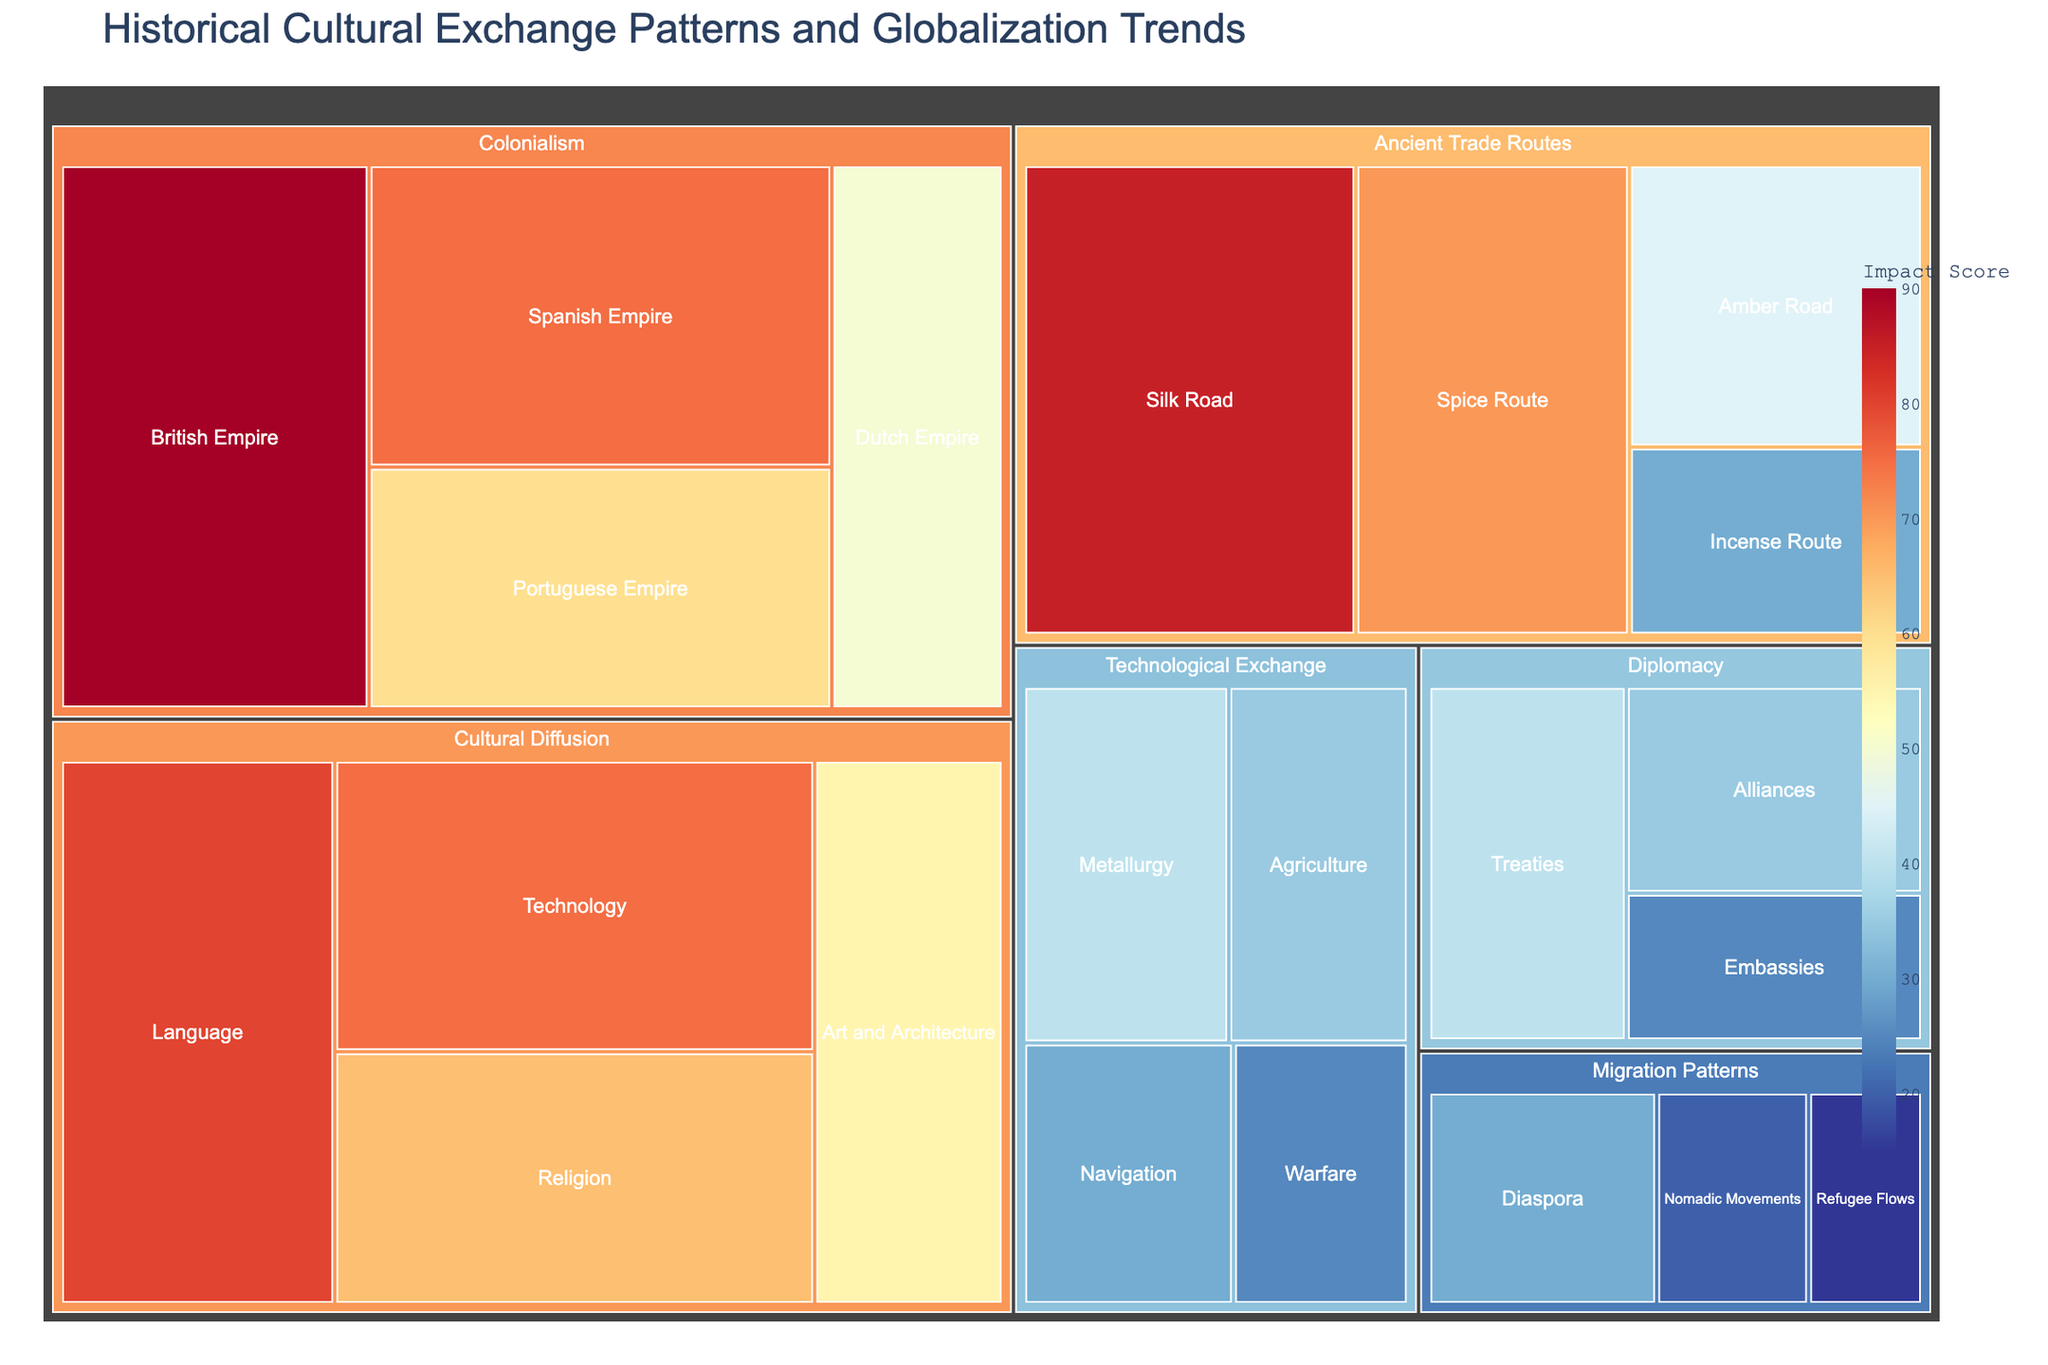What is the title of the figure? The title is typically the first piece of information presented at the top of the plot. In this case, it clearly states the focus of the figure.
Answer: Historical Cultural Exchange Patterns and Globalization Trends Which subcategory has the highest value under "Ancient Trade Routes"? To find the highest value, look at the values associated with each subcategory under "Ancient Trade Routes" and identify the maximum.
Answer: Silk Road Compare the value of "Religion" and "Language" under "Cultural Diffusion". Which one is higher and by how much? Religion has a value of 65, and Language has a value of 80. The difference between them is 80 - 65.
Answer: Language is higher by 15 What is the total value of all subcategories under "Colonialism"? To find the total value, sum the values of the subcategories under "Colonialism" (British Empire 90, Spanish Empire 75, Portuguese Empire 60, Dutch Empire 50). That's 90 + 75 + 60 + 50.
Answer: 275 How does "Navigation" in "Technological Exchange" compare to "Incense Route" in "Ancient Trade Routes" in terms of value? "Navigation" has a value of 30 and "Incense Route" has a value of 30. Since both values are equal, there's no difference between them.
Answer: They are equal What is the average value of the subcategories under "Diplomacy"? Add the values of the subcategories under "Diplomacy" (Treaties 40, Alliances 35, Embassies 25) and divide by the number of subcategories (3). (40 + 35 + 25) / 3 = 33.33.
Answer: 33.33 Which category has the lowest total value when summed up across all its subcategories? Summing up each category's subcategories: 
Ancient Trade Routes = 85+45+70+30 = 230 
Cultural Diffusion = 65+80+55+75 = 275 
Colonialism = 90+75+60+50 = 275 
Diplomacy = 40+35+25 = 100 
Migration Patterns = 20+30+15 = 65 
Technological Exchange = 40+35+30+25 = 130 
The lowest total is for "Migration Patterns".
Answer: Migration Patterns Which subcategories have an equal impact score and what is that score? Checking for subcategories with the same value, we find "Navigation" and "Incense Route" both have a impact score of 30.
Answer: Navigation and Incense Route, score 30 What is the combined impact score of all subcategories that belong to "Technological Exchange"? Sum the values of "Technological Exchange": Metallurgy 40, Agriculture 35, Navigation 30, Warfare 25. That is 40 + 35 + 30 + 25.
Answer: 130 Which category shows a higher impact: "Technological Exchange" or "Cultural Diffusion"? "Technological Exchange" has a combined total of 130 (40+35+30+25) and "Cultural Diffusion" has a total of 275 (65+80+55+75). Therefore, "Cultural Diffusion" has a higher impact.
Answer: Cultural Diffusion 